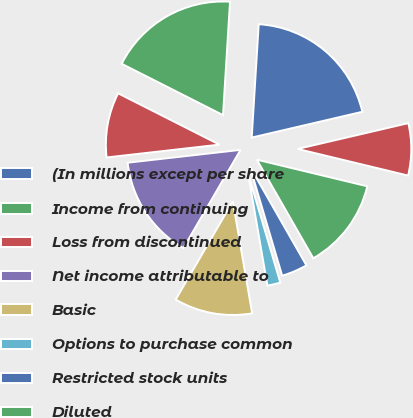Convert chart to OTSL. <chart><loc_0><loc_0><loc_500><loc_500><pie_chart><fcel>(In millions except per share<fcel>Income from continuing<fcel>Loss from discontinued<fcel>Net income attributable to<fcel>Basic<fcel>Options to purchase common<fcel>Restricted stock units<fcel>Diluted<fcel>Continuing operations<nl><fcel>20.37%<fcel>18.52%<fcel>9.26%<fcel>14.81%<fcel>11.11%<fcel>1.85%<fcel>3.7%<fcel>12.96%<fcel>7.41%<nl></chart> 